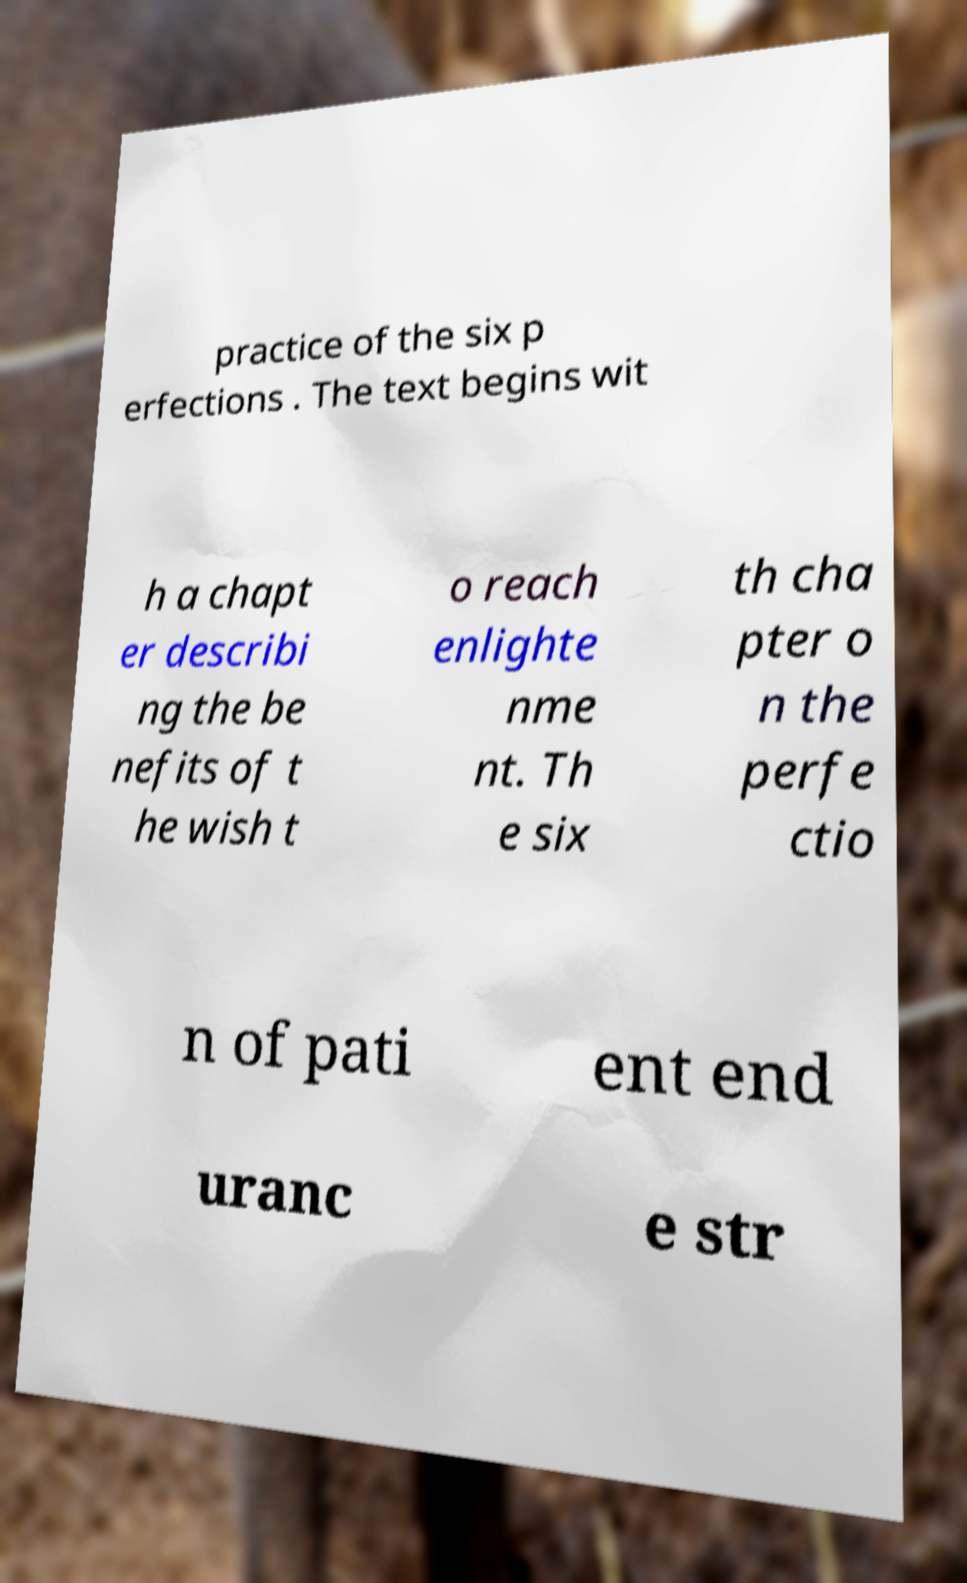For documentation purposes, I need the text within this image transcribed. Could you provide that? practice of the six p erfections . The text begins wit h a chapt er describi ng the be nefits of t he wish t o reach enlighte nme nt. Th e six th cha pter o n the perfe ctio n of pati ent end uranc e str 